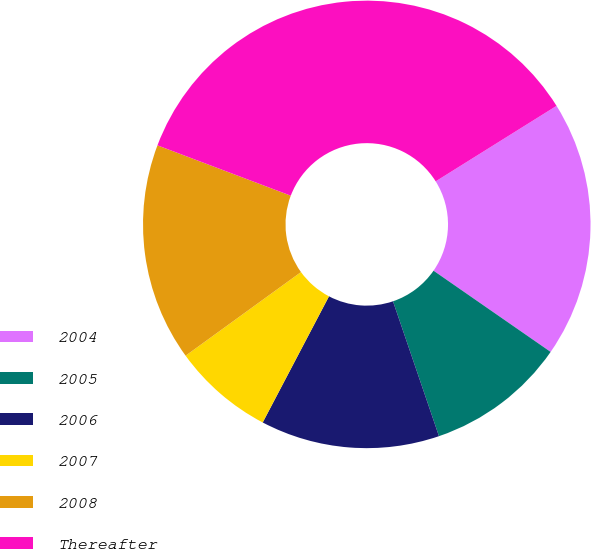Convert chart to OTSL. <chart><loc_0><loc_0><loc_500><loc_500><pie_chart><fcel>2004<fcel>2005<fcel>2006<fcel>2007<fcel>2008<fcel>Thereafter<nl><fcel>18.54%<fcel>10.12%<fcel>12.93%<fcel>7.32%<fcel>15.73%<fcel>35.37%<nl></chart> 